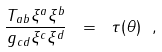<formula> <loc_0><loc_0><loc_500><loc_500>\frac { T _ { a b } \xi ^ { a } \xi ^ { b } } { g _ { c d } \xi ^ { c } \xi ^ { d } } \ = \ \tau ( \theta ) \ ,</formula> 